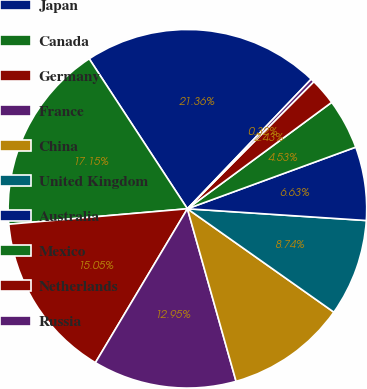Convert chart. <chart><loc_0><loc_0><loc_500><loc_500><pie_chart><fcel>Japan<fcel>Canada<fcel>Germany<fcel>France<fcel>China<fcel>United Kingdom<fcel>Australia<fcel>Mexico<fcel>Netherlands<fcel>Russia<nl><fcel>21.36%<fcel>17.15%<fcel>15.05%<fcel>12.95%<fcel>10.84%<fcel>8.74%<fcel>6.63%<fcel>4.53%<fcel>2.43%<fcel>0.32%<nl></chart> 